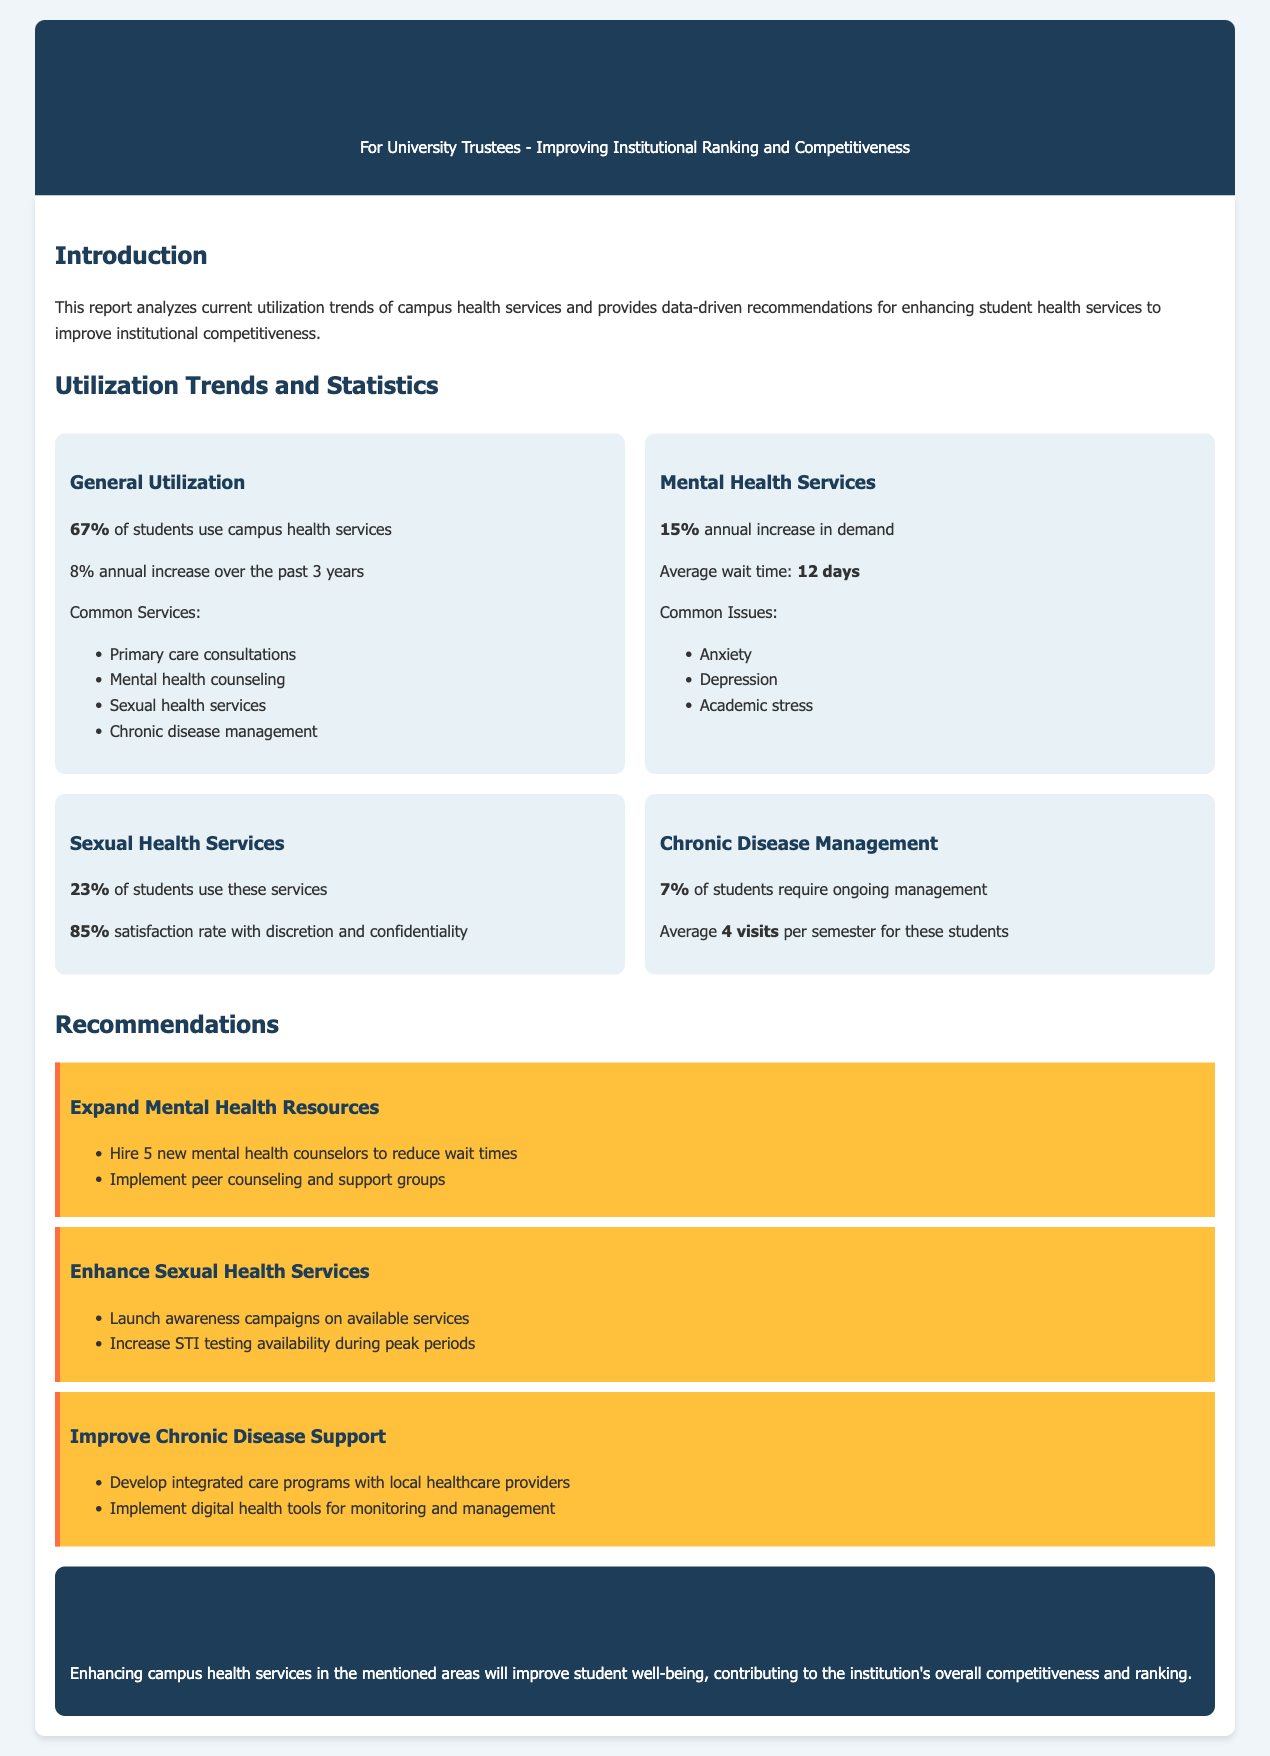What percentage of students use campus health services? The report states that 67% of students utilize campus health services.
Answer: 67% What is the annual increase in general health services utilization over the past 3 years? The document mentions an 8% annual increase in general health services utilization.
Answer: 8% What is the average wait time for mental health services? The report specifies that the average wait time for mental health services is 12 days.
Answer: 12 days What percentage of students use sexual health services? The document indicates that 23% of students use sexual health services.
Answer: 23% How many new mental health counselors are recommended to be hired? The recommendations section suggests hiring 5 new mental health counselors.
Answer: 5 What is the satisfaction rate with sexual health services? The report states that there is an 85% satisfaction rate with sexual health services regarding discretion and confidentiality.
Answer: 85% What percentage of students require chronic disease management? The document notes that 7% of students require ongoing chronic disease management.
Answer: 7% What is the average number of visits per semester for students requiring chronic disease management? According to the report, these students have an average of 4 visits per semester.
Answer: 4 visits What type of counseling programs does the report recommend implementing? The recommendations include implementing peer counseling and support groups.
Answer: Peer counseling and support groups 